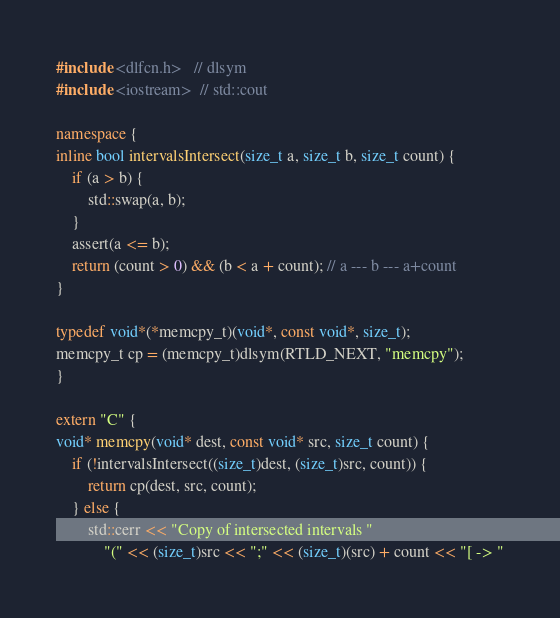<code> <loc_0><loc_0><loc_500><loc_500><_C++_>#include <dlfcn.h>   // dlsym
#include <iostream>  // std::cout

namespace {
inline bool intervalsIntersect(size_t a, size_t b, size_t count) {
    if (a > b) {
        std::swap(a, b);
    }
    assert(a <= b);
    return (count > 0) && (b < a + count); // a --- b --- a+count
}

typedef void*(*memcpy_t)(void*, const void*, size_t);
memcpy_t cp = (memcpy_t)dlsym(RTLD_NEXT, "memcpy");
}

extern "C" {
void* memcpy(void* dest, const void* src, size_t count) {
    if (!intervalsIntersect((size_t)dest, (size_t)src, count)) {
        return cp(dest, src, count);
    } else {
        std::cerr << "Copy of intersected intervals "
            "(" << (size_t)src << ";" << (size_t)(src) + count << "[ -> "</code> 